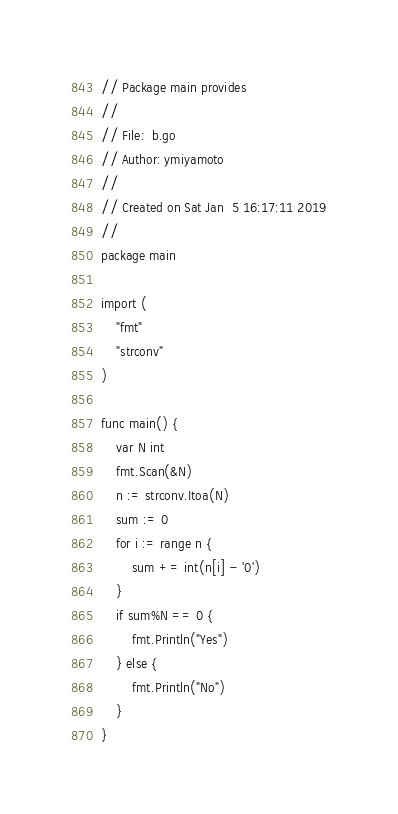<code> <loc_0><loc_0><loc_500><loc_500><_Go_>// Package main provides
//
// File:  b.go
// Author: ymiyamoto
//
// Created on Sat Jan  5 16:17:11 2019
//
package main

import (
	"fmt"
	"strconv"
)

func main() {
	var N int
	fmt.Scan(&N)
	n := strconv.Itoa(N)
	sum := 0
	for i := range n {
		sum += int(n[i] - '0')
	}
	if sum%N == 0 {
		fmt.Println("Yes")
	} else {
		fmt.Println("No")
	}
}
</code> 